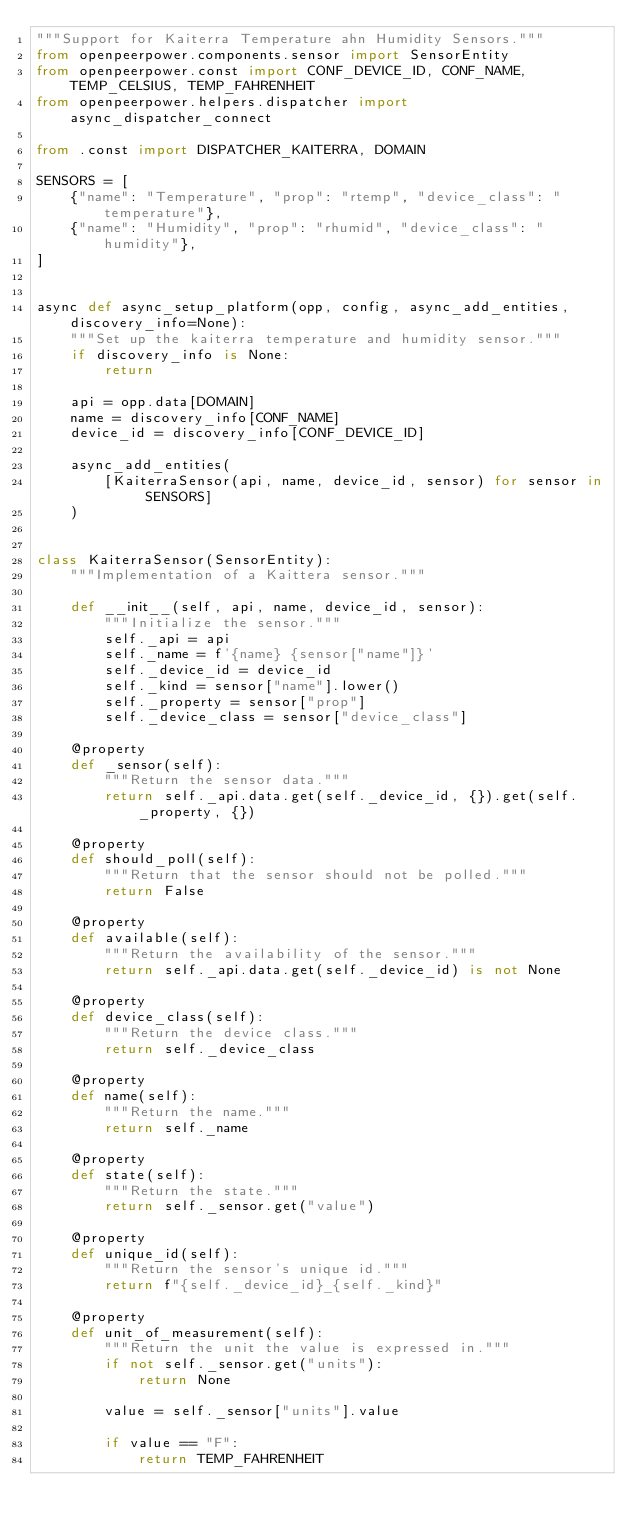<code> <loc_0><loc_0><loc_500><loc_500><_Python_>"""Support for Kaiterra Temperature ahn Humidity Sensors."""
from openpeerpower.components.sensor import SensorEntity
from openpeerpower.const import CONF_DEVICE_ID, CONF_NAME, TEMP_CELSIUS, TEMP_FAHRENHEIT
from openpeerpower.helpers.dispatcher import async_dispatcher_connect

from .const import DISPATCHER_KAITERRA, DOMAIN

SENSORS = [
    {"name": "Temperature", "prop": "rtemp", "device_class": "temperature"},
    {"name": "Humidity", "prop": "rhumid", "device_class": "humidity"},
]


async def async_setup_platform(opp, config, async_add_entities, discovery_info=None):
    """Set up the kaiterra temperature and humidity sensor."""
    if discovery_info is None:
        return

    api = opp.data[DOMAIN]
    name = discovery_info[CONF_NAME]
    device_id = discovery_info[CONF_DEVICE_ID]

    async_add_entities(
        [KaiterraSensor(api, name, device_id, sensor) for sensor in SENSORS]
    )


class KaiterraSensor(SensorEntity):
    """Implementation of a Kaittera sensor."""

    def __init__(self, api, name, device_id, sensor):
        """Initialize the sensor."""
        self._api = api
        self._name = f'{name} {sensor["name"]}'
        self._device_id = device_id
        self._kind = sensor["name"].lower()
        self._property = sensor["prop"]
        self._device_class = sensor["device_class"]

    @property
    def _sensor(self):
        """Return the sensor data."""
        return self._api.data.get(self._device_id, {}).get(self._property, {})

    @property
    def should_poll(self):
        """Return that the sensor should not be polled."""
        return False

    @property
    def available(self):
        """Return the availability of the sensor."""
        return self._api.data.get(self._device_id) is not None

    @property
    def device_class(self):
        """Return the device class."""
        return self._device_class

    @property
    def name(self):
        """Return the name."""
        return self._name

    @property
    def state(self):
        """Return the state."""
        return self._sensor.get("value")

    @property
    def unique_id(self):
        """Return the sensor's unique id."""
        return f"{self._device_id}_{self._kind}"

    @property
    def unit_of_measurement(self):
        """Return the unit the value is expressed in."""
        if not self._sensor.get("units"):
            return None

        value = self._sensor["units"].value

        if value == "F":
            return TEMP_FAHRENHEIT</code> 